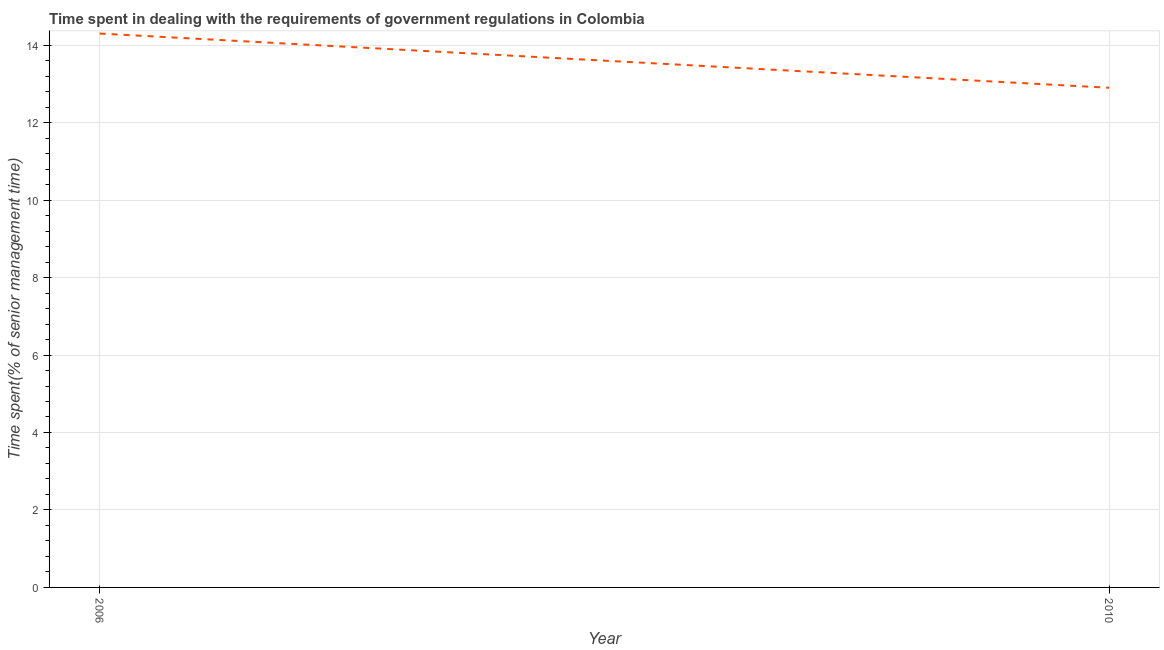Across all years, what is the maximum time spent in dealing with government regulations?
Ensure brevity in your answer.  14.3. In which year was the time spent in dealing with government regulations maximum?
Your answer should be very brief. 2006. In which year was the time spent in dealing with government regulations minimum?
Make the answer very short. 2010. What is the sum of the time spent in dealing with government regulations?
Offer a very short reply. 27.2. What is the difference between the time spent in dealing with government regulations in 2006 and 2010?
Offer a terse response. 1.4. What is the average time spent in dealing with government regulations per year?
Keep it short and to the point. 13.6. What is the median time spent in dealing with government regulations?
Give a very brief answer. 13.6. In how many years, is the time spent in dealing with government regulations greater than 0.4 %?
Offer a very short reply. 2. Do a majority of the years between 2010 and 2006 (inclusive) have time spent in dealing with government regulations greater than 4.8 %?
Your answer should be compact. No. What is the ratio of the time spent in dealing with government regulations in 2006 to that in 2010?
Provide a short and direct response. 1.11. Is the time spent in dealing with government regulations in 2006 less than that in 2010?
Give a very brief answer. No. In how many years, is the time spent in dealing with government regulations greater than the average time spent in dealing with government regulations taken over all years?
Your answer should be very brief. 1. How many lines are there?
Provide a short and direct response. 1. How many years are there in the graph?
Make the answer very short. 2. What is the difference between two consecutive major ticks on the Y-axis?
Your response must be concise. 2. Are the values on the major ticks of Y-axis written in scientific E-notation?
Provide a succinct answer. No. What is the title of the graph?
Your answer should be very brief. Time spent in dealing with the requirements of government regulations in Colombia. What is the label or title of the Y-axis?
Offer a terse response. Time spent(% of senior management time). What is the Time spent(% of senior management time) in 2010?
Give a very brief answer. 12.9. What is the ratio of the Time spent(% of senior management time) in 2006 to that in 2010?
Your answer should be very brief. 1.11. 